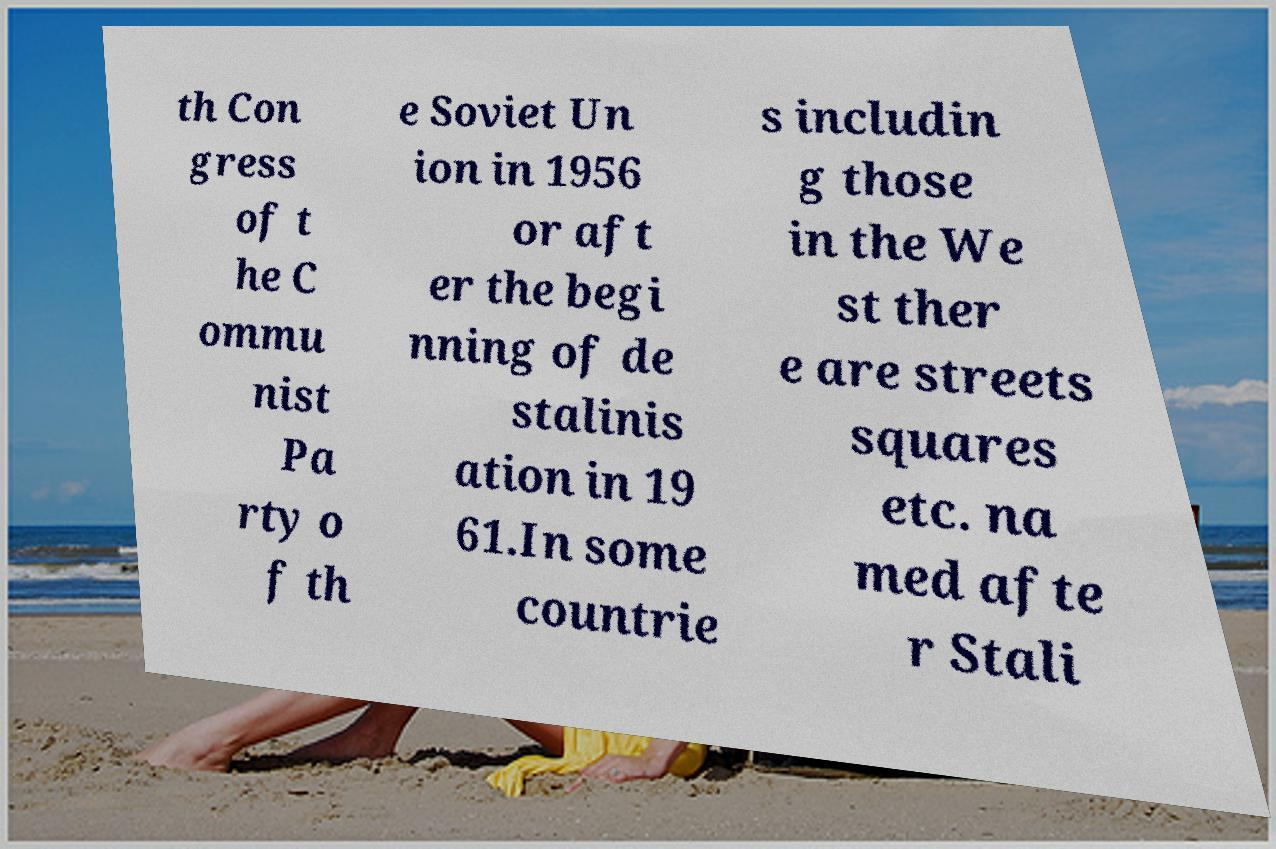Please read and relay the text visible in this image. What does it say? th Con gress of t he C ommu nist Pa rty o f th e Soviet Un ion in 1956 or aft er the begi nning of de stalinis ation in 19 61.In some countrie s includin g those in the We st ther e are streets squares etc. na med afte r Stali 